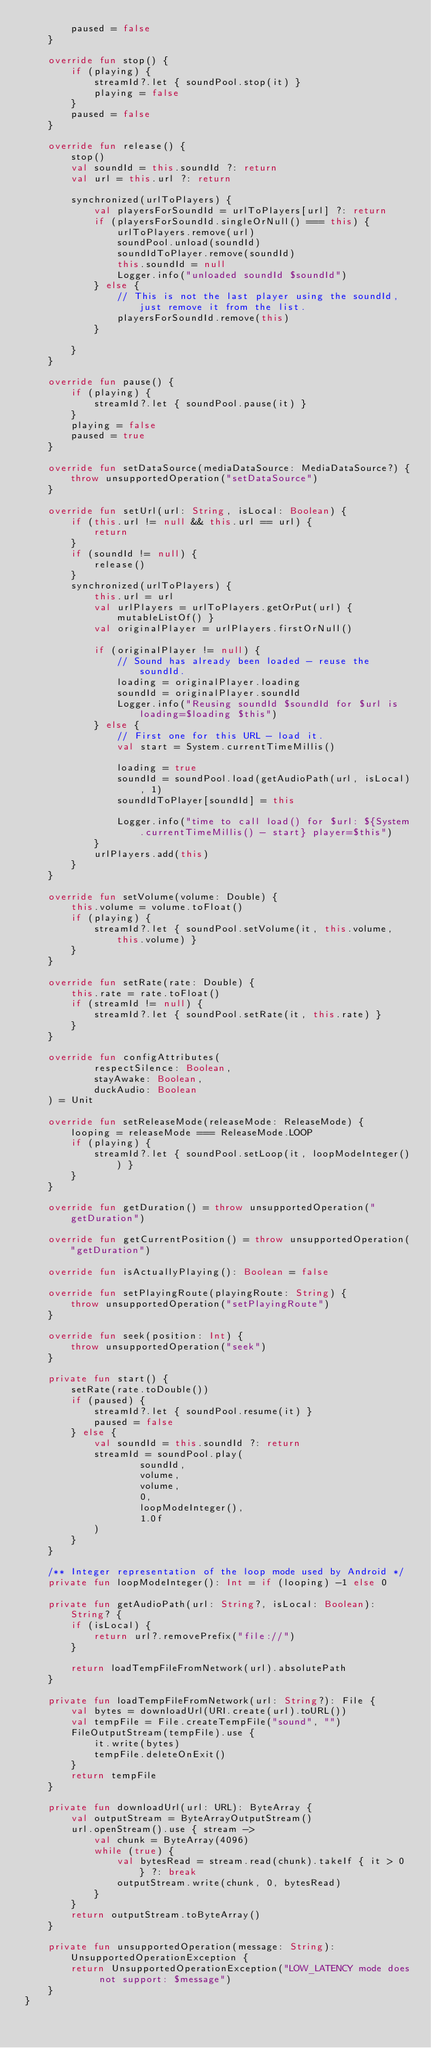Convert code to text. <code><loc_0><loc_0><loc_500><loc_500><_Kotlin_>        paused = false
    }

    override fun stop() {
        if (playing) {
            streamId?.let { soundPool.stop(it) }
            playing = false
        }
        paused = false
    }

    override fun release() {
        stop()
        val soundId = this.soundId ?: return
        val url = this.url ?: return

        synchronized(urlToPlayers) {
            val playersForSoundId = urlToPlayers[url] ?: return
            if (playersForSoundId.singleOrNull() === this) {
                urlToPlayers.remove(url)
                soundPool.unload(soundId)
                soundIdToPlayer.remove(soundId)
                this.soundId = null
                Logger.info("unloaded soundId $soundId")
            } else {
                // This is not the last player using the soundId, just remove it from the list.
                playersForSoundId.remove(this)
            }

        }
    }

    override fun pause() {
        if (playing) {
            streamId?.let { soundPool.pause(it) }
        }
        playing = false
        paused = true
    }

    override fun setDataSource(mediaDataSource: MediaDataSource?) {
        throw unsupportedOperation("setDataSource")
    }

    override fun setUrl(url: String, isLocal: Boolean) {
        if (this.url != null && this.url == url) {
            return
        }
        if (soundId != null) {
            release()
        }
        synchronized(urlToPlayers) {
            this.url = url
            val urlPlayers = urlToPlayers.getOrPut(url) { mutableListOf() }
            val originalPlayer = urlPlayers.firstOrNull()

            if (originalPlayer != null) {
                // Sound has already been loaded - reuse the soundId.
                loading = originalPlayer.loading
                soundId = originalPlayer.soundId
                Logger.info("Reusing soundId $soundId for $url is loading=$loading $this")
            } else {
                // First one for this URL - load it.
                val start = System.currentTimeMillis()

                loading = true
                soundId = soundPool.load(getAudioPath(url, isLocal), 1)
                soundIdToPlayer[soundId] = this

                Logger.info("time to call load() for $url: ${System.currentTimeMillis() - start} player=$this")
            }
            urlPlayers.add(this)
        }
    }

    override fun setVolume(volume: Double) {
        this.volume = volume.toFloat()
        if (playing) {
            streamId?.let { soundPool.setVolume(it, this.volume, this.volume) }
        }
    }

    override fun setRate(rate: Double) {
        this.rate = rate.toFloat()
        if (streamId != null) {
            streamId?.let { soundPool.setRate(it, this.rate) }
        }
    }

    override fun configAttributes(
            respectSilence: Boolean,
            stayAwake: Boolean,
            duckAudio: Boolean
    ) = Unit

    override fun setReleaseMode(releaseMode: ReleaseMode) {
        looping = releaseMode === ReleaseMode.LOOP
        if (playing) {
            streamId?.let { soundPool.setLoop(it, loopModeInteger()) }
        }
    }

    override fun getDuration() = throw unsupportedOperation("getDuration")

    override fun getCurrentPosition() = throw unsupportedOperation("getDuration")

    override fun isActuallyPlaying(): Boolean = false

    override fun setPlayingRoute(playingRoute: String) {
        throw unsupportedOperation("setPlayingRoute")
    }

    override fun seek(position: Int) {
        throw unsupportedOperation("seek")
    }

    private fun start() {
        setRate(rate.toDouble())
        if (paused) {
            streamId?.let { soundPool.resume(it) }
            paused = false
        } else {
            val soundId = this.soundId ?: return
            streamId = soundPool.play(
                    soundId,
                    volume,
                    volume,
                    0,
                    loopModeInteger(),
                    1.0f
            )
        }
    }

    /** Integer representation of the loop mode used by Android */
    private fun loopModeInteger(): Int = if (looping) -1 else 0

    private fun getAudioPath(url: String?, isLocal: Boolean): String? {
        if (isLocal) {
            return url?.removePrefix("file://")
        }

        return loadTempFileFromNetwork(url).absolutePath
    }

    private fun loadTempFileFromNetwork(url: String?): File {
        val bytes = downloadUrl(URI.create(url).toURL())
        val tempFile = File.createTempFile("sound", "")
        FileOutputStream(tempFile).use {
            it.write(bytes)
            tempFile.deleteOnExit()
        }
        return tempFile
    }

    private fun downloadUrl(url: URL): ByteArray {
        val outputStream = ByteArrayOutputStream()
        url.openStream().use { stream ->
            val chunk = ByteArray(4096)
            while (true) {
                val bytesRead = stream.read(chunk).takeIf { it > 0 } ?: break
                outputStream.write(chunk, 0, bytesRead)
            }
        }
        return outputStream.toByteArray()
    }

    private fun unsupportedOperation(message: String): UnsupportedOperationException {
        return UnsupportedOperationException("LOW_LATENCY mode does not support: $message")
    }
}
</code> 